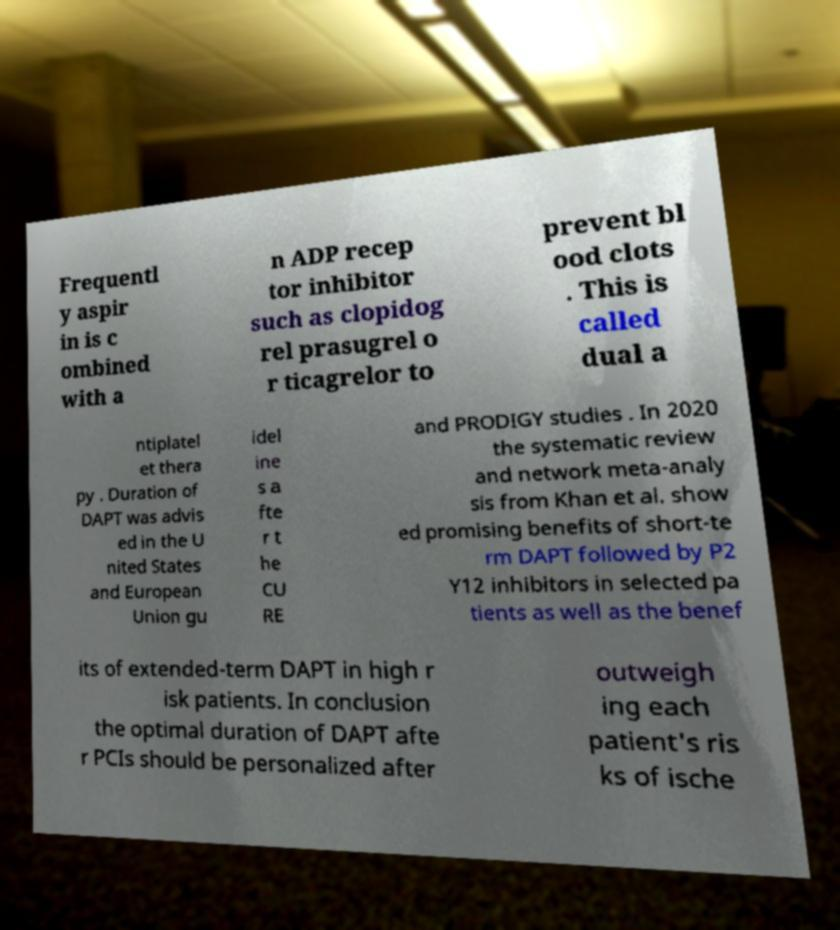Could you extract and type out the text from this image? Frequentl y aspir in is c ombined with a n ADP recep tor inhibitor such as clopidog rel prasugrel o r ticagrelor to prevent bl ood clots . This is called dual a ntiplatel et thera py . Duration of DAPT was advis ed in the U nited States and European Union gu idel ine s a fte r t he CU RE and PRODIGY studies . In 2020 the systematic review and network meta-analy sis from Khan et al. show ed promising benefits of short-te rm DAPT followed by P2 Y12 inhibitors in selected pa tients as well as the benef its of extended-term DAPT in high r isk patients. In conclusion the optimal duration of DAPT afte r PCIs should be personalized after outweigh ing each patient's ris ks of ische 